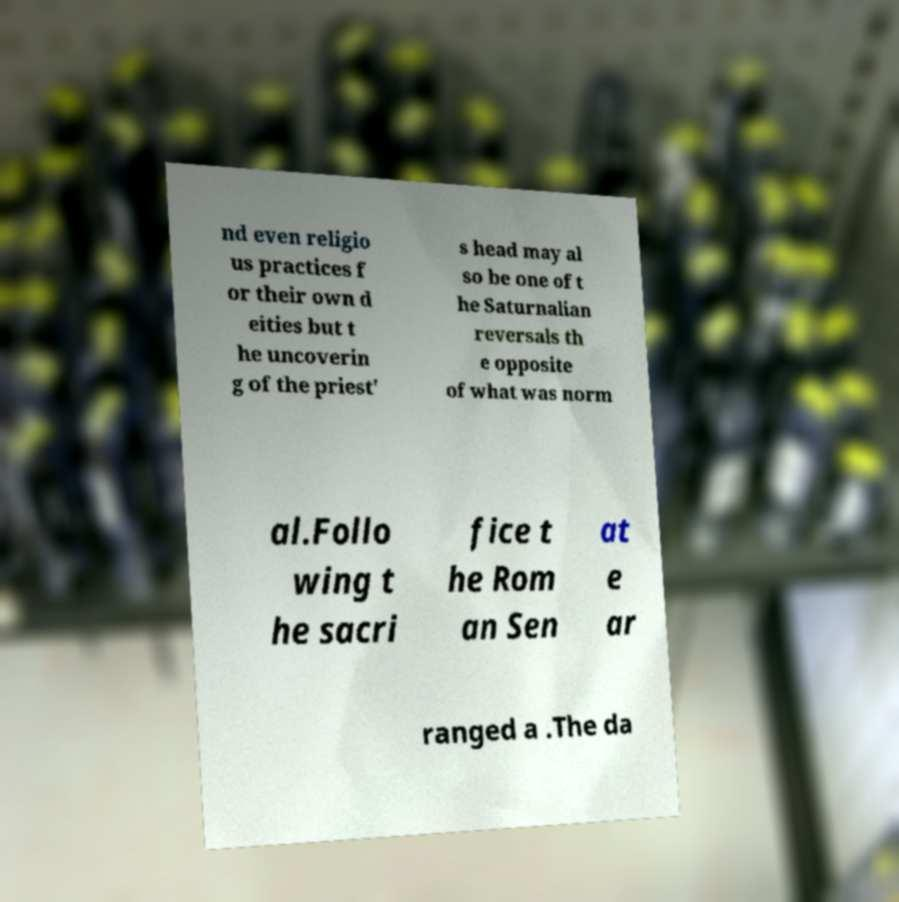Could you assist in decoding the text presented in this image and type it out clearly? nd even religio us practices f or their own d eities but t he uncoverin g of the priest' s head may al so be one of t he Saturnalian reversals th e opposite of what was norm al.Follo wing t he sacri fice t he Rom an Sen at e ar ranged a .The da 